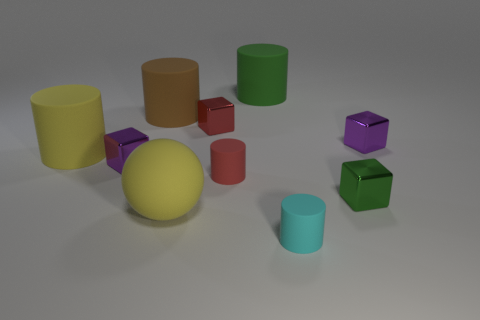Subtract all big brown rubber cylinders. How many cylinders are left? 4 Subtract all green blocks. How many blocks are left? 3 Subtract 3 cylinders. How many cylinders are left? 2 Subtract all gray cylinders. How many cyan blocks are left? 0 Subtract all blocks. How many objects are left? 6 Subtract all cyan rubber objects. Subtract all red cubes. How many objects are left? 8 Add 8 small red objects. How many small red objects are left? 10 Add 4 small red shiny blocks. How many small red shiny blocks exist? 5 Subtract 0 cyan cubes. How many objects are left? 10 Subtract all brown blocks. Subtract all brown balls. How many blocks are left? 4 